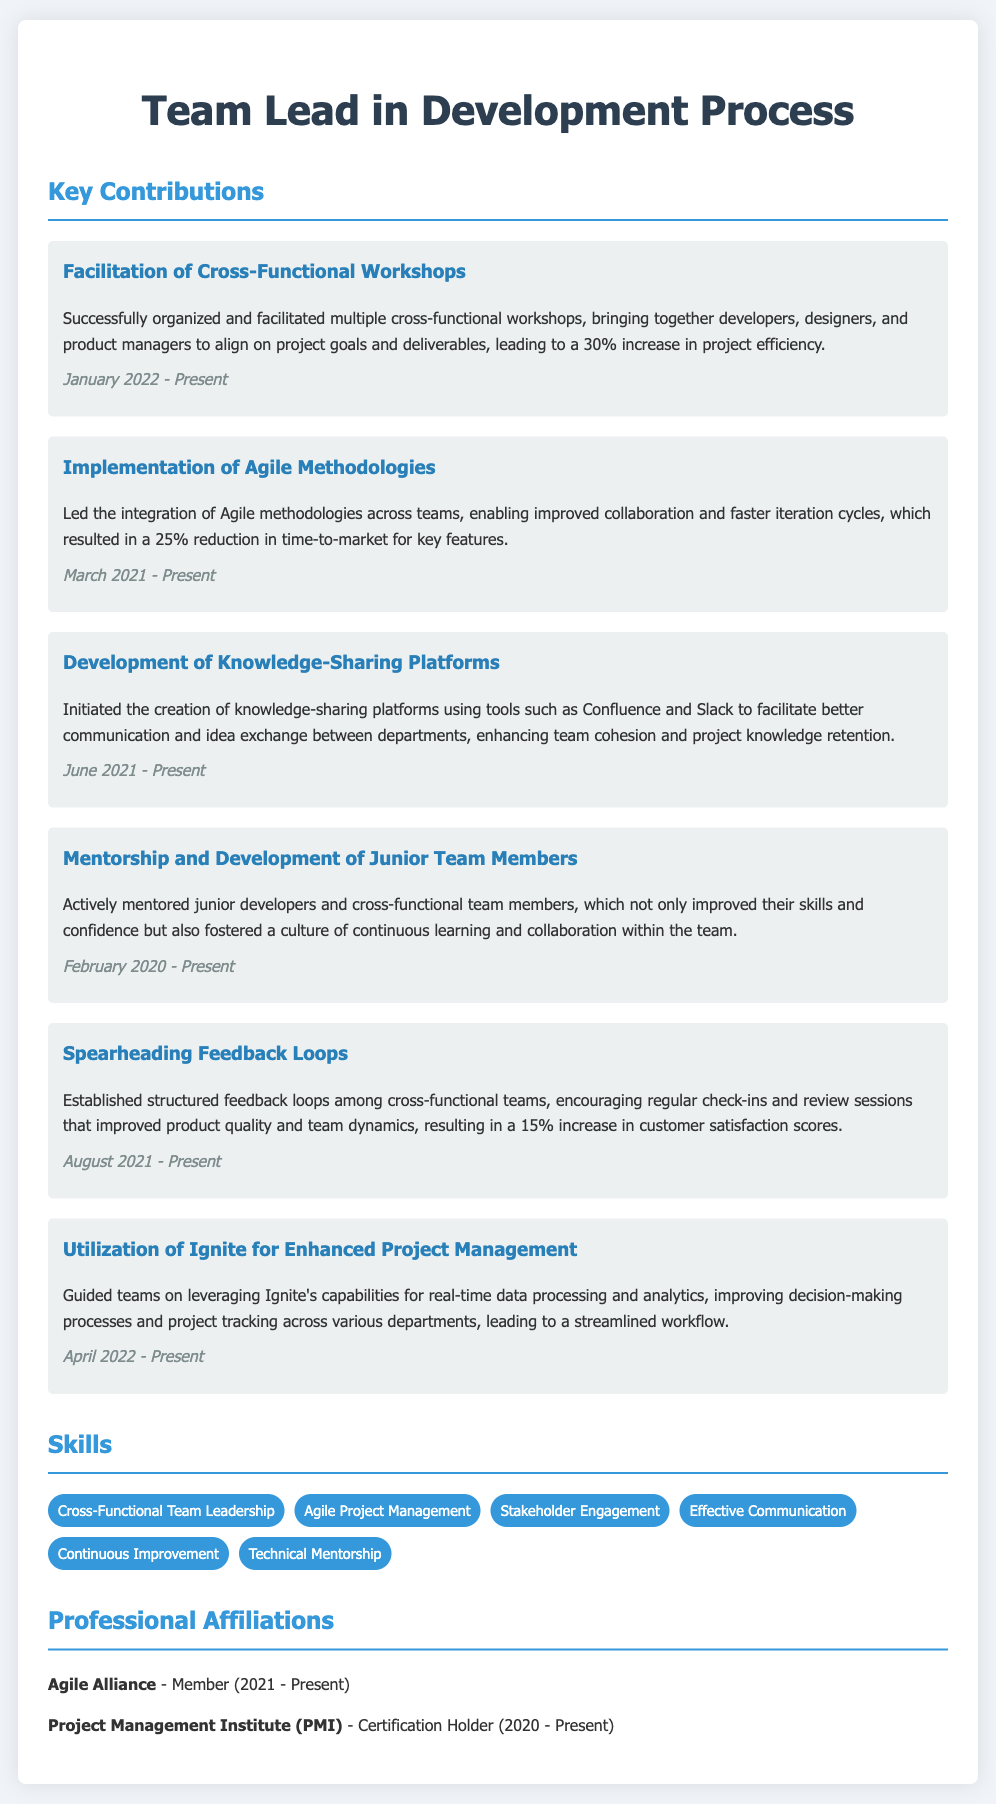What is the title of the CV? The title of the CV is prominently displayed at the top, indicating the individual's role and expertise in development processes.
Answer: Team Lead in Development Process When did the person start mentoring junior team members? The document states the starting date for mentoring junior team members, which shows their commitment to developing talent.
Answer: February 2020 Which workshop was organized to enhance project efficiency? The document mentions a specific type of collaboration that was facilitated to achieve better project outcomes.
Answer: Cross-Functional Workshops What percentage increase in customer satisfaction scores resulted from establishing feedback loops? The document provides a clear metric that reflects the effectiveness of feedback loops in enhancing team dynamics and product quality.
Answer: 15% Which tool was mentioned as part of the knowledge-sharing platform? The document lists tools used for improving communication and sharing ideas among teams.
Answer: Confluence How much was the reduction in time-to-market achieved through Agile methodologies? The document specifies the achievement related to Agile methodologies, showing a quantifiable impact on project timelines.
Answer: 25% 